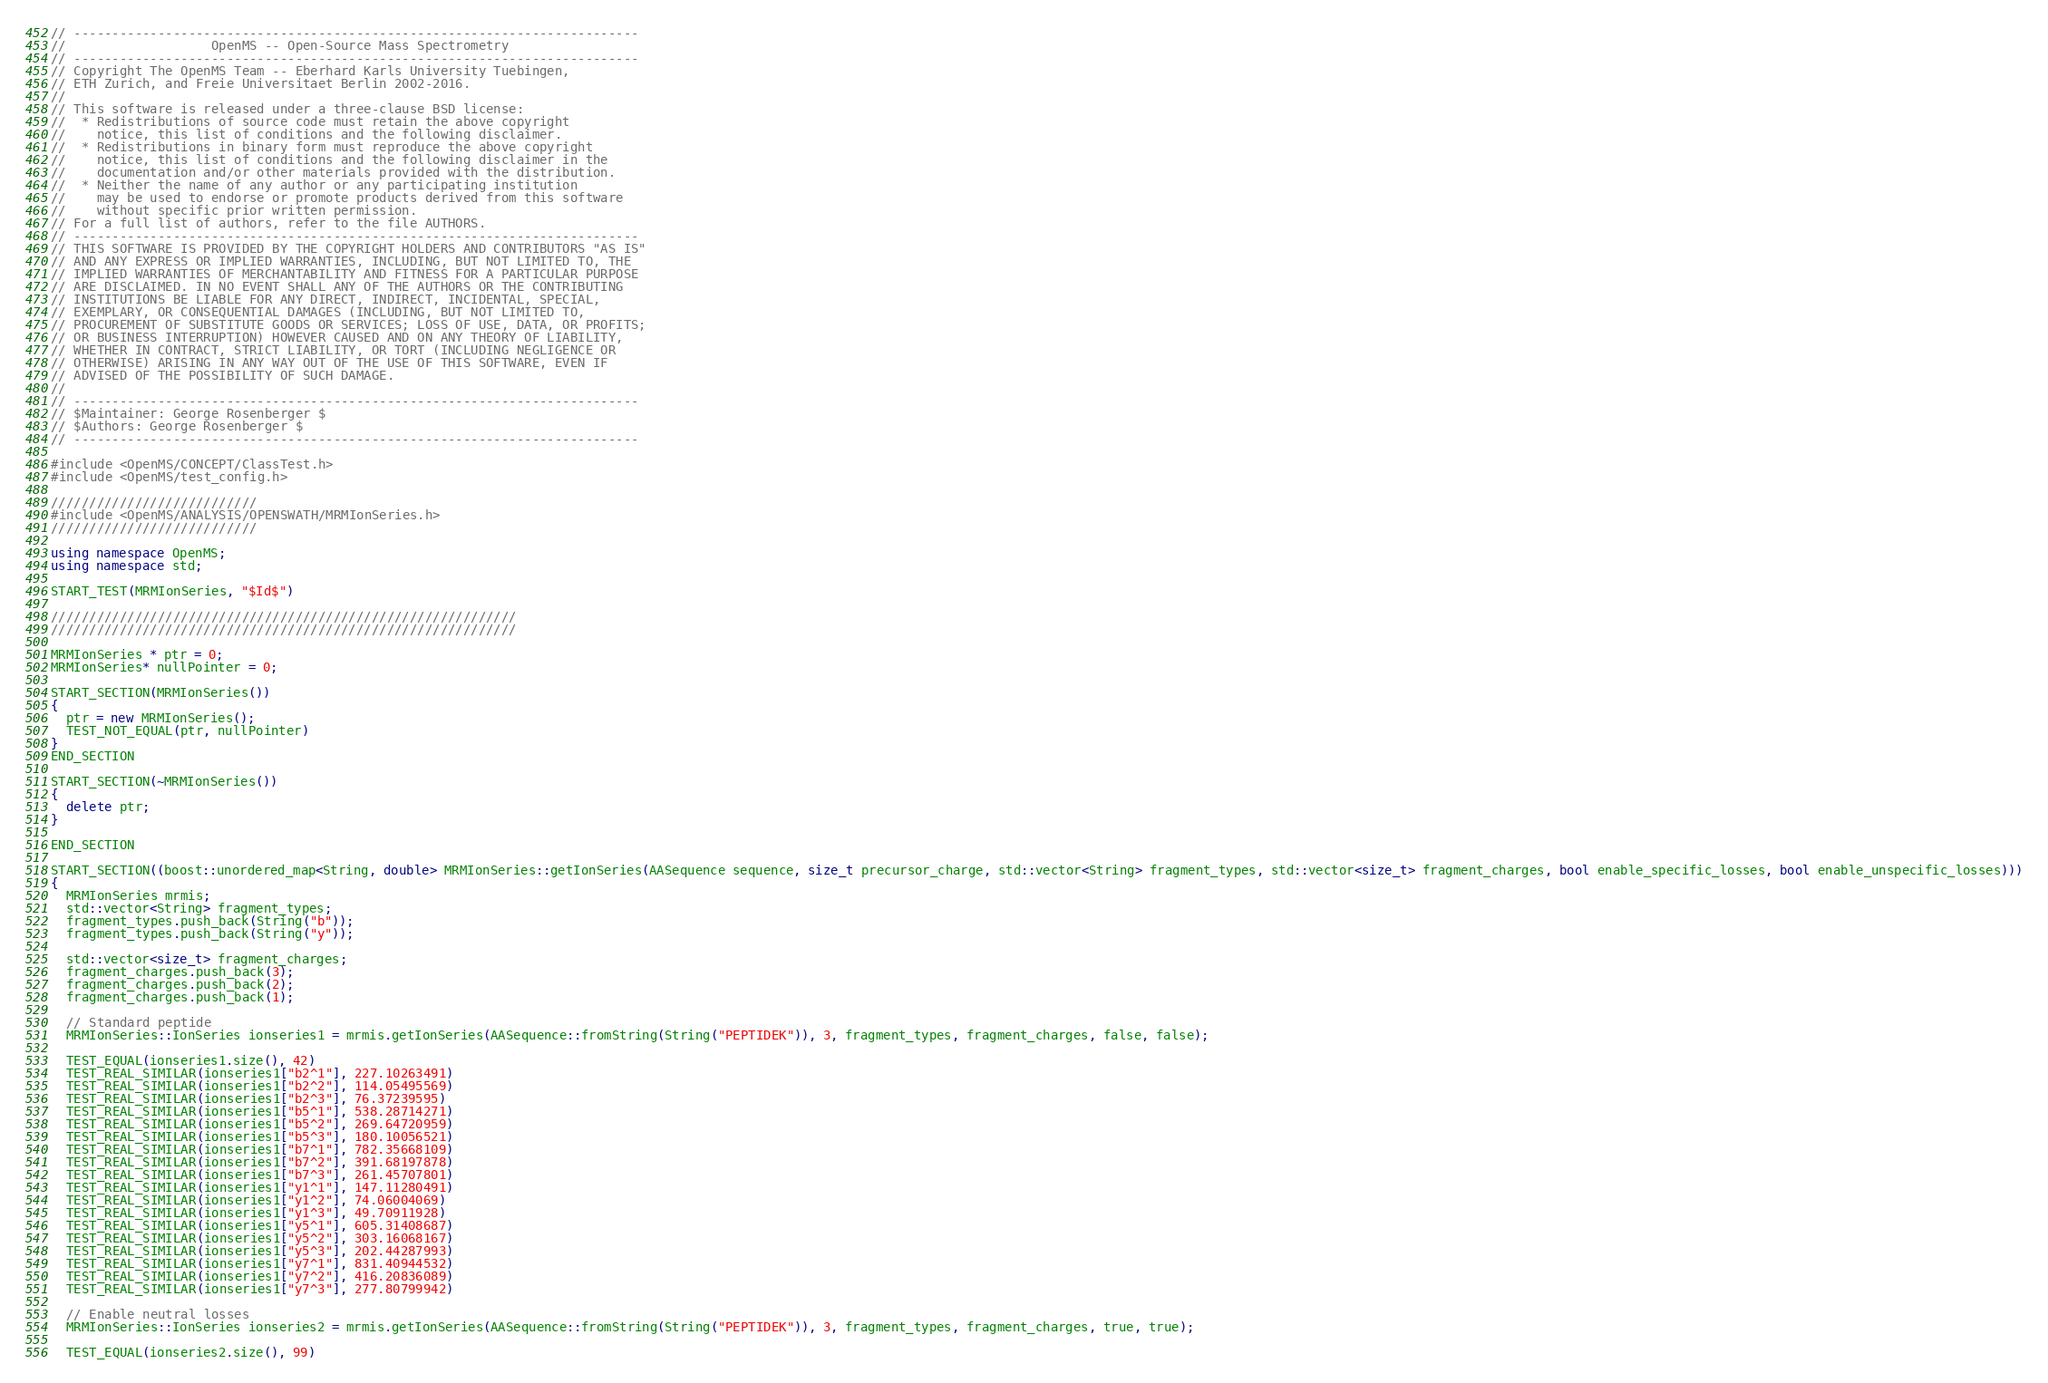<code> <loc_0><loc_0><loc_500><loc_500><_C++_>// --------------------------------------------------------------------------
//                   OpenMS -- Open-Source Mass Spectrometry
// --------------------------------------------------------------------------
// Copyright The OpenMS Team -- Eberhard Karls University Tuebingen,
// ETH Zurich, and Freie Universitaet Berlin 2002-2016.
//
// This software is released under a three-clause BSD license:
//  * Redistributions of source code must retain the above copyright
//    notice, this list of conditions and the following disclaimer.
//  * Redistributions in binary form must reproduce the above copyright
//    notice, this list of conditions and the following disclaimer in the
//    documentation and/or other materials provided with the distribution.
//  * Neither the name of any author or any participating institution
//    may be used to endorse or promote products derived from this software
//    without specific prior written permission.
// For a full list of authors, refer to the file AUTHORS.
// --------------------------------------------------------------------------
// THIS SOFTWARE IS PROVIDED BY THE COPYRIGHT HOLDERS AND CONTRIBUTORS "AS IS"
// AND ANY EXPRESS OR IMPLIED WARRANTIES, INCLUDING, BUT NOT LIMITED TO, THE
// IMPLIED WARRANTIES OF MERCHANTABILITY AND FITNESS FOR A PARTICULAR PURPOSE
// ARE DISCLAIMED. IN NO EVENT SHALL ANY OF THE AUTHORS OR THE CONTRIBUTING
// INSTITUTIONS BE LIABLE FOR ANY DIRECT, INDIRECT, INCIDENTAL, SPECIAL,
// EXEMPLARY, OR CONSEQUENTIAL DAMAGES (INCLUDING, BUT NOT LIMITED TO,
// PROCUREMENT OF SUBSTITUTE GOODS OR SERVICES; LOSS OF USE, DATA, OR PROFITS;
// OR BUSINESS INTERRUPTION) HOWEVER CAUSED AND ON ANY THEORY OF LIABILITY,
// WHETHER IN CONTRACT, STRICT LIABILITY, OR TORT (INCLUDING NEGLIGENCE OR
// OTHERWISE) ARISING IN ANY WAY OUT OF THE USE OF THIS SOFTWARE, EVEN IF
// ADVISED OF THE POSSIBILITY OF SUCH DAMAGE.
//
// --------------------------------------------------------------------------
// $Maintainer: George Rosenberger $
// $Authors: George Rosenberger $
// --------------------------------------------------------------------------

#include <OpenMS/CONCEPT/ClassTest.h>
#include <OpenMS/test_config.h>

///////////////////////////
#include <OpenMS/ANALYSIS/OPENSWATH/MRMIonSeries.h>
///////////////////////////

using namespace OpenMS;
using namespace std;

START_TEST(MRMIonSeries, "$Id$")

/////////////////////////////////////////////////////////////
/////////////////////////////////////////////////////////////

MRMIonSeries * ptr = 0;
MRMIonSeries* nullPointer = 0;

START_SECTION(MRMIonSeries())
{
  ptr = new MRMIonSeries();
  TEST_NOT_EQUAL(ptr, nullPointer)
}
END_SECTION

START_SECTION(~MRMIonSeries())
{
  delete ptr;
}

END_SECTION

START_SECTION((boost::unordered_map<String, double> MRMIonSeries::getIonSeries(AASequence sequence, size_t precursor_charge, std::vector<String> fragment_types, std::vector<size_t> fragment_charges, bool enable_specific_losses, bool enable_unspecific_losses)))
{
  MRMIonSeries mrmis;
  std::vector<String> fragment_types;
  fragment_types.push_back(String("b"));
  fragment_types.push_back(String("y"));

  std::vector<size_t> fragment_charges;
  fragment_charges.push_back(3);
  fragment_charges.push_back(2);
  fragment_charges.push_back(1);

  // Standard peptide
  MRMIonSeries::IonSeries ionseries1 = mrmis.getIonSeries(AASequence::fromString(String("PEPTIDEK")), 3, fragment_types, fragment_charges, false, false);

  TEST_EQUAL(ionseries1.size(), 42)
  TEST_REAL_SIMILAR(ionseries1["b2^1"], 227.10263491)
  TEST_REAL_SIMILAR(ionseries1["b2^2"], 114.05495569)
  TEST_REAL_SIMILAR(ionseries1["b2^3"], 76.37239595)
  TEST_REAL_SIMILAR(ionseries1["b5^1"], 538.28714271)
  TEST_REAL_SIMILAR(ionseries1["b5^2"], 269.64720959)
  TEST_REAL_SIMILAR(ionseries1["b5^3"], 180.10056521)
  TEST_REAL_SIMILAR(ionseries1["b7^1"], 782.35668109)
  TEST_REAL_SIMILAR(ionseries1["b7^2"], 391.68197878)
  TEST_REAL_SIMILAR(ionseries1["b7^3"], 261.45707801)
  TEST_REAL_SIMILAR(ionseries1["y1^1"], 147.11280491)
  TEST_REAL_SIMILAR(ionseries1["y1^2"], 74.06004069)
  TEST_REAL_SIMILAR(ionseries1["y1^3"], 49.70911928)
  TEST_REAL_SIMILAR(ionseries1["y5^1"], 605.31408687)
  TEST_REAL_SIMILAR(ionseries1["y5^2"], 303.16068167)
  TEST_REAL_SIMILAR(ionseries1["y5^3"], 202.44287993)
  TEST_REAL_SIMILAR(ionseries1["y7^1"], 831.40944532)
  TEST_REAL_SIMILAR(ionseries1["y7^2"], 416.20836089)
  TEST_REAL_SIMILAR(ionseries1["y7^3"], 277.80799942)

  // Enable neutral losses
  MRMIonSeries::IonSeries ionseries2 = mrmis.getIonSeries(AASequence::fromString(String("PEPTIDEK")), 3, fragment_types, fragment_charges, true, true);

  TEST_EQUAL(ionseries2.size(), 99)</code> 